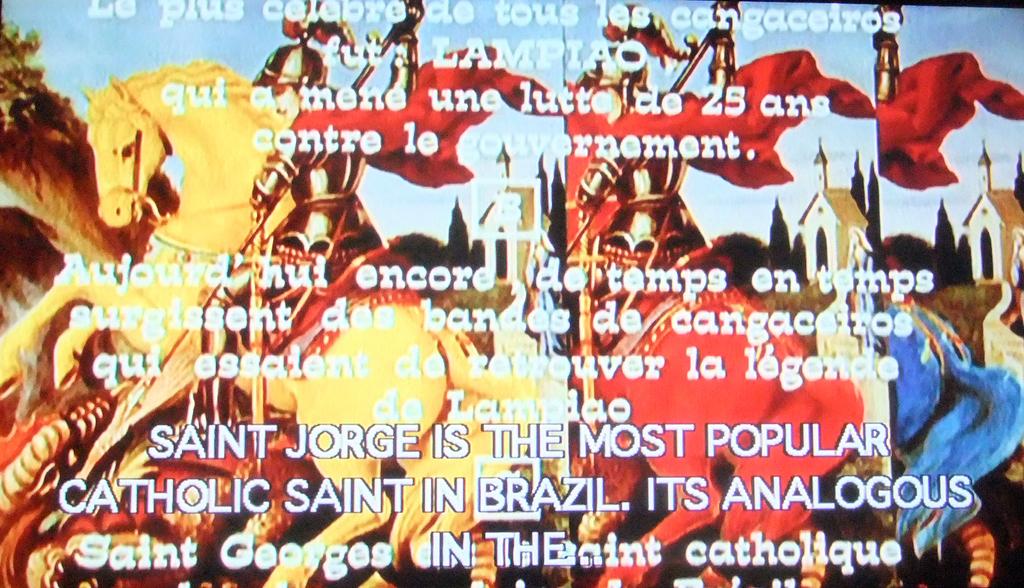Who is the most popular catholic saint in brazil?
Your answer should be very brief. Saint jorge. 